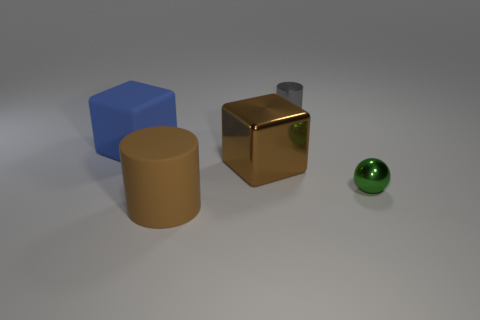Add 5 brown objects. How many objects exist? 10 Subtract all brown blocks. How many blocks are left? 1 Subtract all balls. How many objects are left? 4 Subtract 1 cylinders. How many cylinders are left? 1 Subtract all green cylinders. Subtract all green balls. How many cylinders are left? 2 Add 5 small gray things. How many small gray things exist? 6 Subtract 1 brown blocks. How many objects are left? 4 Subtract all gray cylinders. How many brown cubes are left? 1 Subtract all cylinders. Subtract all large blue blocks. How many objects are left? 2 Add 1 metal cubes. How many metal cubes are left? 2 